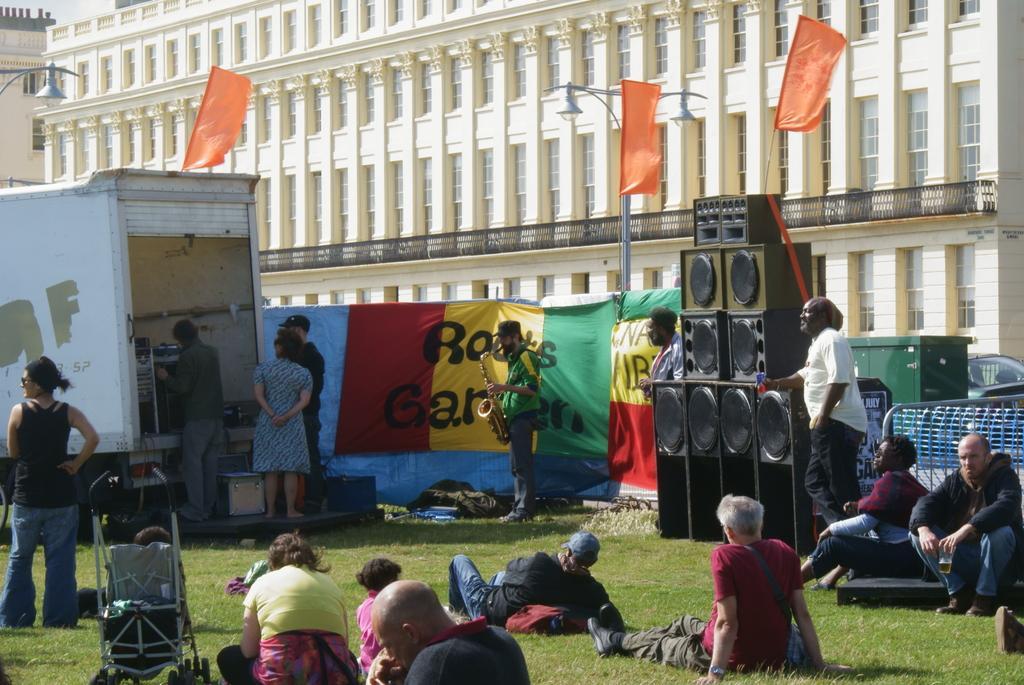Can you describe this image briefly? On the left side of the image we can see a truck, amplifier, chair are present. On the right side of the image we can see speakers, flags, poles, lights, fencing, car are there. In the center of the image we can see a man is standing and holding a trumpet in his hand. At the bottom of the image some persons are there. In the middle of the image we can see a board, bag are present. At the top of the image a building is there. At the bottom of the image ground is present. 